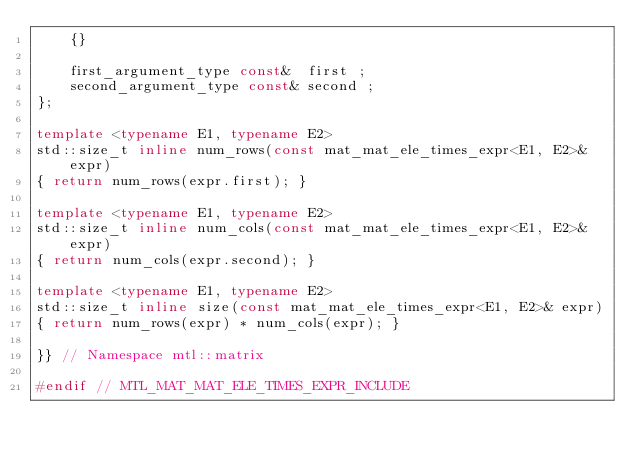<code> <loc_0><loc_0><loc_500><loc_500><_C++_>    {}

    first_argument_type const&  first ;
    second_argument_type const& second ;
};

template <typename E1, typename E2>
std::size_t inline num_rows(const mat_mat_ele_times_expr<E1, E2>& expr) 
{ return num_rows(expr.first); }

template <typename E1, typename E2>
std::size_t inline num_cols(const mat_mat_ele_times_expr<E1, E2>& expr) 
{ return num_cols(expr.second); }

template <typename E1, typename E2>
std::size_t inline size(const mat_mat_ele_times_expr<E1, E2>& expr) 
{ return num_rows(expr) * num_cols(expr); }

}} // Namespace mtl::matrix

#endif // MTL_MAT_MAT_ELE_TIMES_EXPR_INCLUDE
</code> 